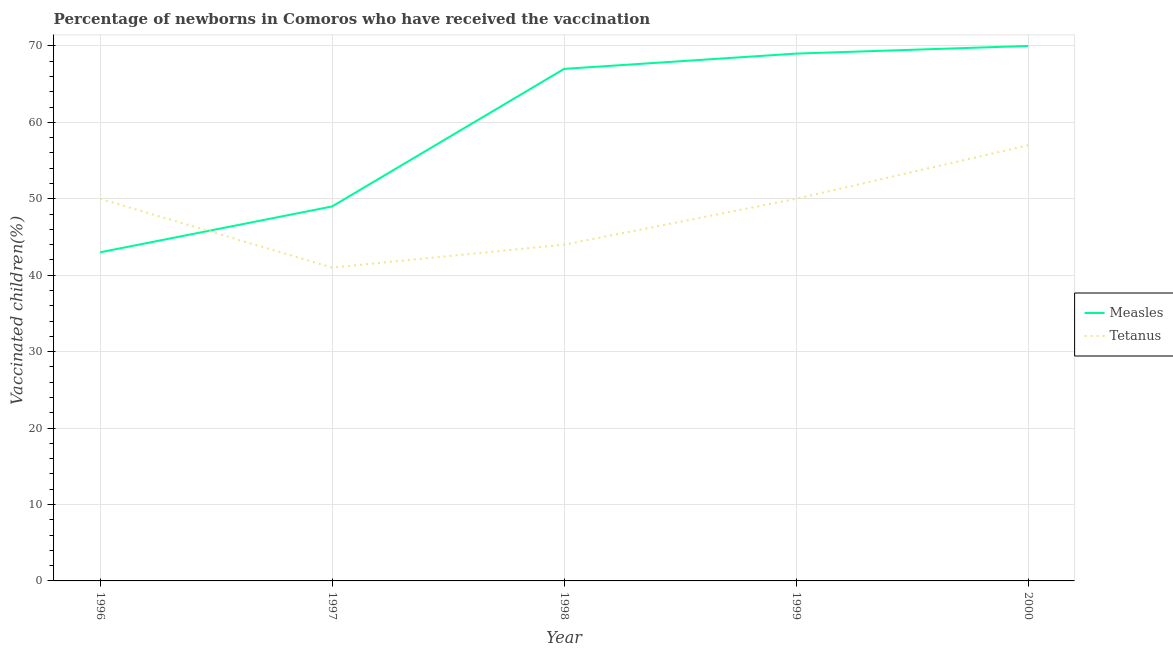What is the percentage of newborns who received vaccination for tetanus in 1996?
Offer a very short reply. 50. Across all years, what is the maximum percentage of newborns who received vaccination for measles?
Make the answer very short. 70. Across all years, what is the minimum percentage of newborns who received vaccination for measles?
Keep it short and to the point. 43. In which year was the percentage of newborns who received vaccination for tetanus maximum?
Keep it short and to the point. 2000. What is the total percentage of newborns who received vaccination for tetanus in the graph?
Your answer should be compact. 242. What is the difference between the percentage of newborns who received vaccination for tetanus in 1999 and that in 2000?
Your answer should be compact. -7. What is the difference between the percentage of newborns who received vaccination for tetanus in 1996 and the percentage of newborns who received vaccination for measles in 2000?
Your response must be concise. -20. What is the average percentage of newborns who received vaccination for tetanus per year?
Provide a short and direct response. 48.4. In the year 1997, what is the difference between the percentage of newborns who received vaccination for measles and percentage of newborns who received vaccination for tetanus?
Give a very brief answer. 8. In how many years, is the percentage of newborns who received vaccination for tetanus greater than 66 %?
Provide a short and direct response. 0. What is the ratio of the percentage of newborns who received vaccination for tetanus in 1997 to that in 1998?
Make the answer very short. 0.93. Is the percentage of newborns who received vaccination for measles in 1999 less than that in 2000?
Make the answer very short. Yes. What is the difference between the highest and the lowest percentage of newborns who received vaccination for tetanus?
Your response must be concise. 16. Is the sum of the percentage of newborns who received vaccination for tetanus in 1999 and 2000 greater than the maximum percentage of newborns who received vaccination for measles across all years?
Offer a very short reply. Yes. Does the percentage of newborns who received vaccination for tetanus monotonically increase over the years?
Offer a terse response. No. Is the percentage of newborns who received vaccination for tetanus strictly greater than the percentage of newborns who received vaccination for measles over the years?
Keep it short and to the point. No. Is the percentage of newborns who received vaccination for measles strictly less than the percentage of newborns who received vaccination for tetanus over the years?
Your answer should be very brief. No. How many lines are there?
Make the answer very short. 2. What is the difference between two consecutive major ticks on the Y-axis?
Your answer should be compact. 10. Are the values on the major ticks of Y-axis written in scientific E-notation?
Keep it short and to the point. No. Does the graph contain any zero values?
Your response must be concise. No. Does the graph contain grids?
Ensure brevity in your answer.  Yes. How are the legend labels stacked?
Your response must be concise. Vertical. What is the title of the graph?
Your answer should be very brief. Percentage of newborns in Comoros who have received the vaccination. Does "Male" appear as one of the legend labels in the graph?
Provide a short and direct response. No. What is the label or title of the Y-axis?
Provide a succinct answer. Vaccinated children(%)
. What is the Vaccinated children(%)
 of Tetanus in 1996?
Give a very brief answer. 50. What is the Vaccinated children(%)
 in Measles in 1997?
Provide a short and direct response. 49. What is the Vaccinated children(%)
 in Tetanus in 1999?
Your response must be concise. 50. What is the Vaccinated children(%)
 of Measles in 2000?
Your answer should be very brief. 70. What is the Vaccinated children(%)
 of Tetanus in 2000?
Make the answer very short. 57. Across all years, what is the maximum Vaccinated children(%)
 of Measles?
Offer a terse response. 70. Across all years, what is the maximum Vaccinated children(%)
 in Tetanus?
Offer a very short reply. 57. Across all years, what is the minimum Vaccinated children(%)
 of Measles?
Keep it short and to the point. 43. Across all years, what is the minimum Vaccinated children(%)
 of Tetanus?
Ensure brevity in your answer.  41. What is the total Vaccinated children(%)
 in Measles in the graph?
Offer a very short reply. 298. What is the total Vaccinated children(%)
 in Tetanus in the graph?
Keep it short and to the point. 242. What is the difference between the Vaccinated children(%)
 in Tetanus in 1996 and that in 1997?
Your response must be concise. 9. What is the difference between the Vaccinated children(%)
 of Measles in 1996 and that in 1998?
Keep it short and to the point. -24. What is the difference between the Vaccinated children(%)
 in Tetanus in 1996 and that in 1998?
Your response must be concise. 6. What is the difference between the Vaccinated children(%)
 in Tetanus in 1996 and that in 1999?
Your answer should be compact. 0. What is the difference between the Vaccinated children(%)
 of Measles in 1996 and that in 2000?
Give a very brief answer. -27. What is the difference between the Vaccinated children(%)
 of Tetanus in 1996 and that in 2000?
Your answer should be very brief. -7. What is the difference between the Vaccinated children(%)
 of Tetanus in 1997 and that in 1998?
Offer a very short reply. -3. What is the difference between the Vaccinated children(%)
 of Tetanus in 1998 and that in 1999?
Provide a succinct answer. -6. What is the difference between the Vaccinated children(%)
 of Tetanus in 1999 and that in 2000?
Provide a short and direct response. -7. What is the difference between the Vaccinated children(%)
 in Measles in 1996 and the Vaccinated children(%)
 in Tetanus in 1998?
Make the answer very short. -1. What is the difference between the Vaccinated children(%)
 of Measles in 1996 and the Vaccinated children(%)
 of Tetanus in 2000?
Ensure brevity in your answer.  -14. What is the difference between the Vaccinated children(%)
 in Measles in 1997 and the Vaccinated children(%)
 in Tetanus in 1998?
Ensure brevity in your answer.  5. What is the difference between the Vaccinated children(%)
 in Measles in 1997 and the Vaccinated children(%)
 in Tetanus in 2000?
Ensure brevity in your answer.  -8. What is the difference between the Vaccinated children(%)
 of Measles in 1998 and the Vaccinated children(%)
 of Tetanus in 2000?
Your answer should be very brief. 10. What is the difference between the Vaccinated children(%)
 of Measles in 1999 and the Vaccinated children(%)
 of Tetanus in 2000?
Make the answer very short. 12. What is the average Vaccinated children(%)
 of Measles per year?
Offer a very short reply. 59.6. What is the average Vaccinated children(%)
 in Tetanus per year?
Make the answer very short. 48.4. In the year 1996, what is the difference between the Vaccinated children(%)
 in Measles and Vaccinated children(%)
 in Tetanus?
Give a very brief answer. -7. In the year 1997, what is the difference between the Vaccinated children(%)
 of Measles and Vaccinated children(%)
 of Tetanus?
Your answer should be compact. 8. In the year 1998, what is the difference between the Vaccinated children(%)
 in Measles and Vaccinated children(%)
 in Tetanus?
Give a very brief answer. 23. In the year 2000, what is the difference between the Vaccinated children(%)
 of Measles and Vaccinated children(%)
 of Tetanus?
Your answer should be very brief. 13. What is the ratio of the Vaccinated children(%)
 of Measles in 1996 to that in 1997?
Offer a very short reply. 0.88. What is the ratio of the Vaccinated children(%)
 in Tetanus in 1996 to that in 1997?
Make the answer very short. 1.22. What is the ratio of the Vaccinated children(%)
 in Measles in 1996 to that in 1998?
Offer a terse response. 0.64. What is the ratio of the Vaccinated children(%)
 in Tetanus in 1996 to that in 1998?
Offer a terse response. 1.14. What is the ratio of the Vaccinated children(%)
 in Measles in 1996 to that in 1999?
Your answer should be compact. 0.62. What is the ratio of the Vaccinated children(%)
 of Measles in 1996 to that in 2000?
Offer a terse response. 0.61. What is the ratio of the Vaccinated children(%)
 in Tetanus in 1996 to that in 2000?
Offer a very short reply. 0.88. What is the ratio of the Vaccinated children(%)
 of Measles in 1997 to that in 1998?
Your answer should be very brief. 0.73. What is the ratio of the Vaccinated children(%)
 in Tetanus in 1997 to that in 1998?
Provide a succinct answer. 0.93. What is the ratio of the Vaccinated children(%)
 in Measles in 1997 to that in 1999?
Make the answer very short. 0.71. What is the ratio of the Vaccinated children(%)
 of Tetanus in 1997 to that in 1999?
Provide a succinct answer. 0.82. What is the ratio of the Vaccinated children(%)
 in Tetanus in 1997 to that in 2000?
Your answer should be very brief. 0.72. What is the ratio of the Vaccinated children(%)
 in Measles in 1998 to that in 1999?
Ensure brevity in your answer.  0.97. What is the ratio of the Vaccinated children(%)
 of Measles in 1998 to that in 2000?
Ensure brevity in your answer.  0.96. What is the ratio of the Vaccinated children(%)
 in Tetanus in 1998 to that in 2000?
Offer a terse response. 0.77. What is the ratio of the Vaccinated children(%)
 of Measles in 1999 to that in 2000?
Make the answer very short. 0.99. What is the ratio of the Vaccinated children(%)
 in Tetanus in 1999 to that in 2000?
Make the answer very short. 0.88. What is the difference between the highest and the second highest Vaccinated children(%)
 of Measles?
Offer a very short reply. 1. What is the difference between the highest and the lowest Vaccinated children(%)
 in Tetanus?
Your answer should be compact. 16. 